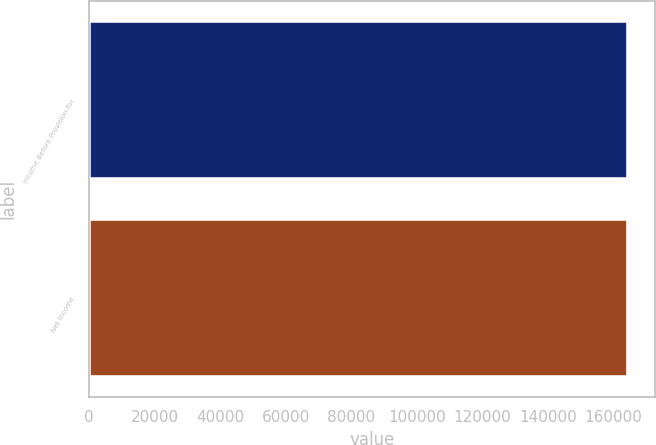<chart> <loc_0><loc_0><loc_500><loc_500><bar_chart><fcel>Income Before Provision for<fcel>Net Income<nl><fcel>164267<fcel>164267<nl></chart> 